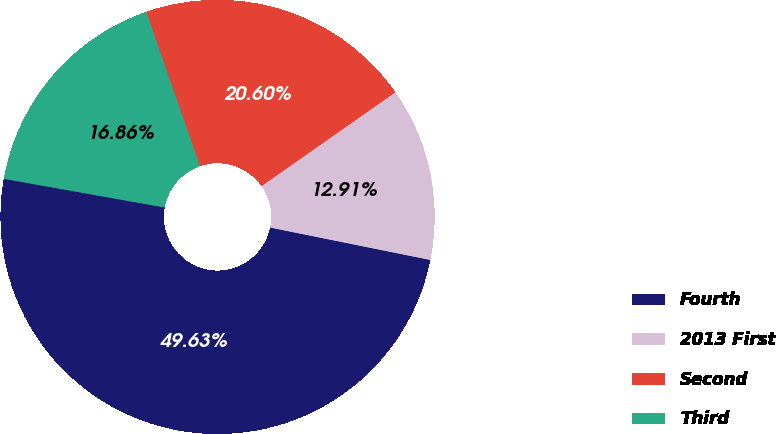Convert chart. <chart><loc_0><loc_0><loc_500><loc_500><pie_chart><fcel>Fourth<fcel>2013 First<fcel>Second<fcel>Third<nl><fcel>49.63%<fcel>12.91%<fcel>20.6%<fcel>16.86%<nl></chart> 